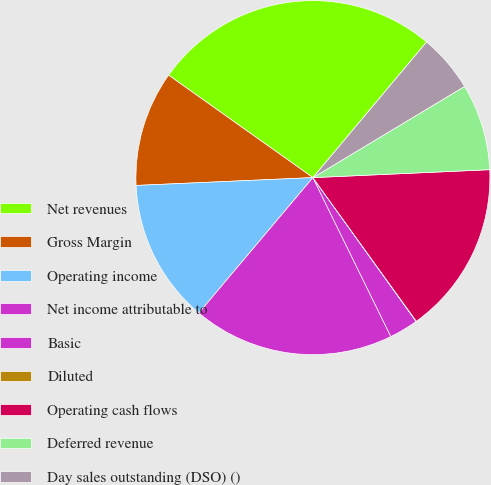Convert chart. <chart><loc_0><loc_0><loc_500><loc_500><pie_chart><fcel>Net revenues<fcel>Gross Margin<fcel>Operating income<fcel>Net income attributable to<fcel>Basic<fcel>Diluted<fcel>Operating cash flows<fcel>Deferred revenue<fcel>Day sales outstanding (DSO) ()<nl><fcel>26.28%<fcel>10.53%<fcel>13.15%<fcel>18.4%<fcel>2.65%<fcel>0.03%<fcel>15.78%<fcel>7.9%<fcel>5.28%<nl></chart> 